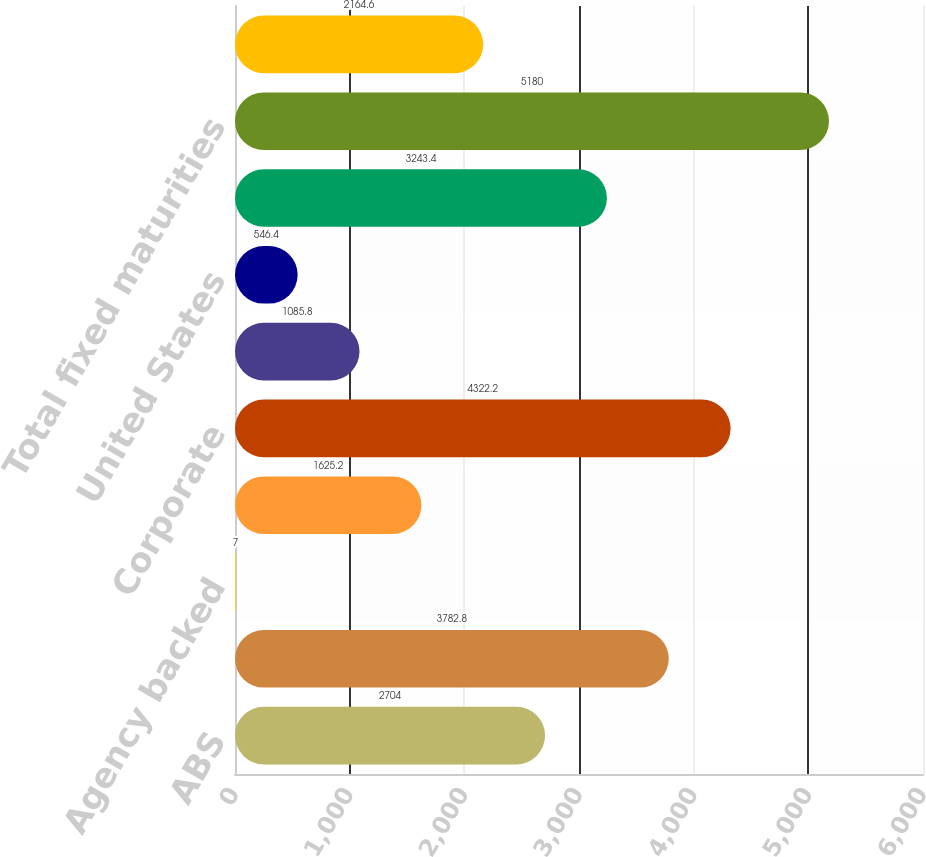Convert chart to OTSL. <chart><loc_0><loc_0><loc_500><loc_500><bar_chart><fcel>ABS<fcel>CMBS - Non-agency backed<fcel>Agency backed<fcel>Non-agency backed<fcel>Corporate<fcel>Foreign<fcel>United States<fcel>States municipalities and<fcel>Total fixed maturities<fcel>Equity securities available-<nl><fcel>2704<fcel>3782.8<fcel>7<fcel>1625.2<fcel>4322.2<fcel>1085.8<fcel>546.4<fcel>3243.4<fcel>5180<fcel>2164.6<nl></chart> 